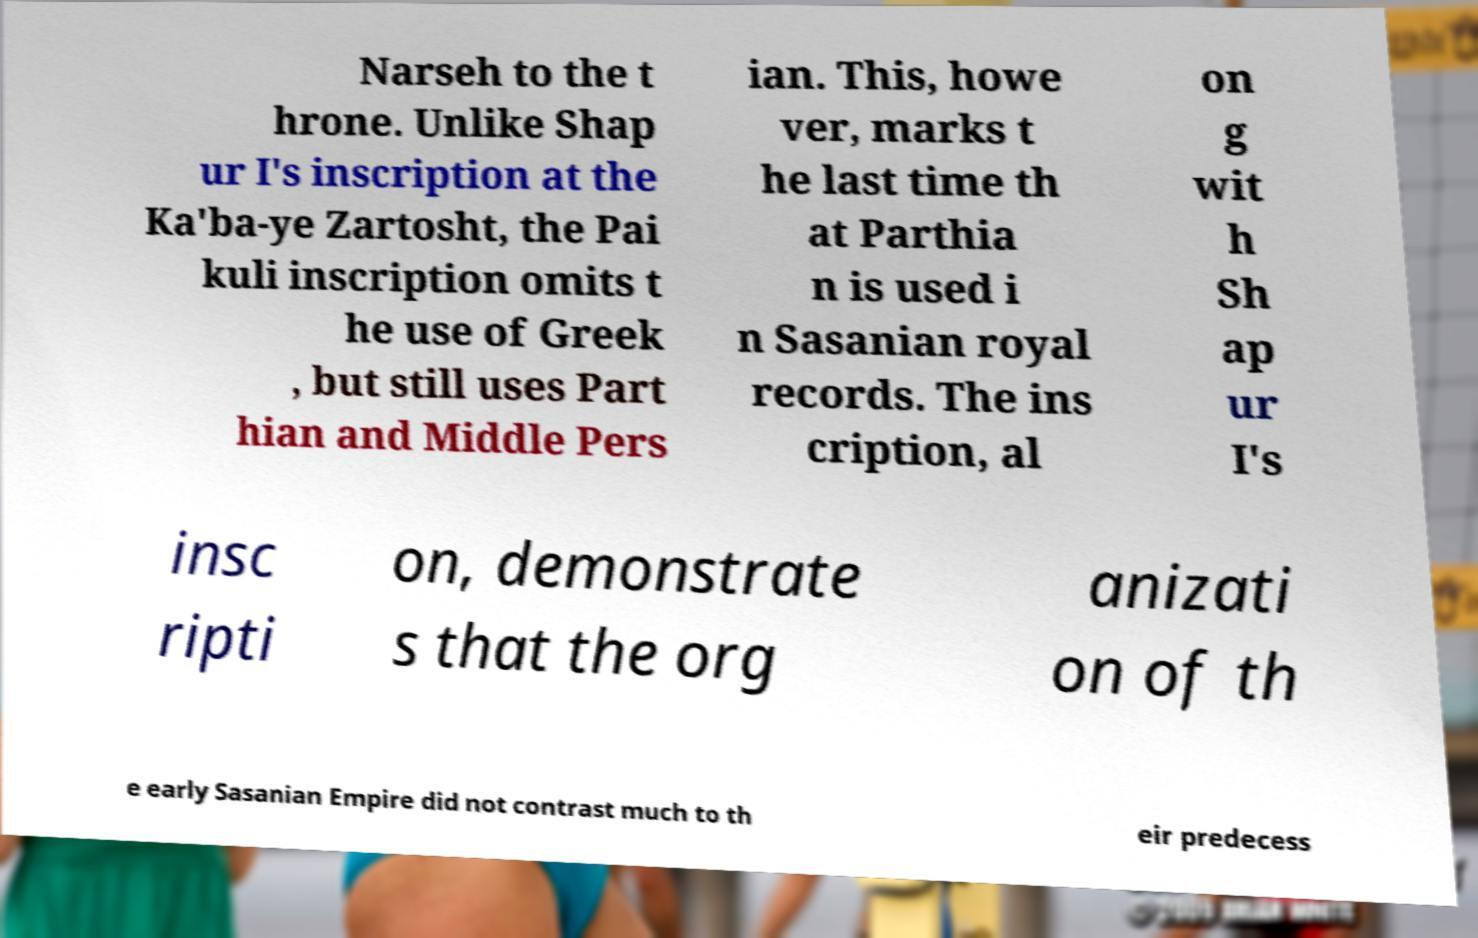There's text embedded in this image that I need extracted. Can you transcribe it verbatim? Narseh to the t hrone. Unlike Shap ur I's inscription at the Ka'ba-ye Zartosht, the Pai kuli inscription omits t he use of Greek , but still uses Part hian and Middle Pers ian. This, howe ver, marks t he last time th at Parthia n is used i n Sasanian royal records. The ins cription, al on g wit h Sh ap ur I's insc ripti on, demonstrate s that the org anizati on of th e early Sasanian Empire did not contrast much to th eir predecess 